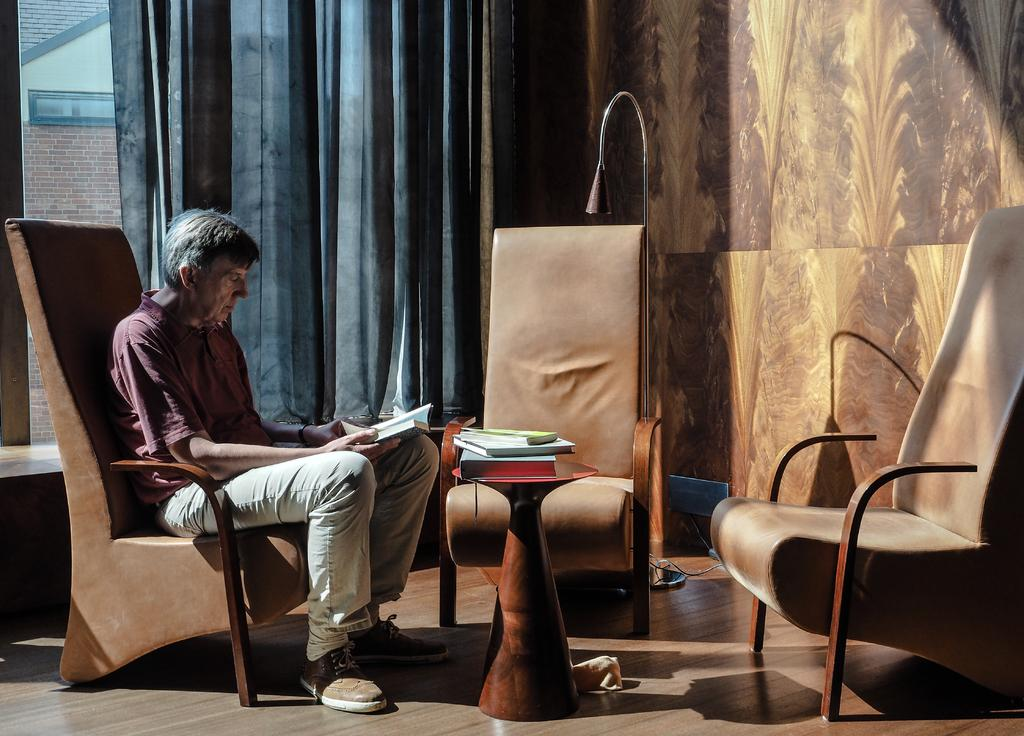What is the person in the image doing? The person is sitting on a chair in the image. What is the person holding? The person is holding a book. What else can be seen on the table in the image? There are books on a table in the image. How many chairs are visible in the image? There are chairs in the image. What type of window treatment is present in the image? There is a curtain in the image. What material is the wall made of in the image? There is a wooden wall in the image. What type of lighting is present in the image? There is a lamp in the image. What type of meat is being cooked on the stove in the image? There is no stove or meat present in the image. 